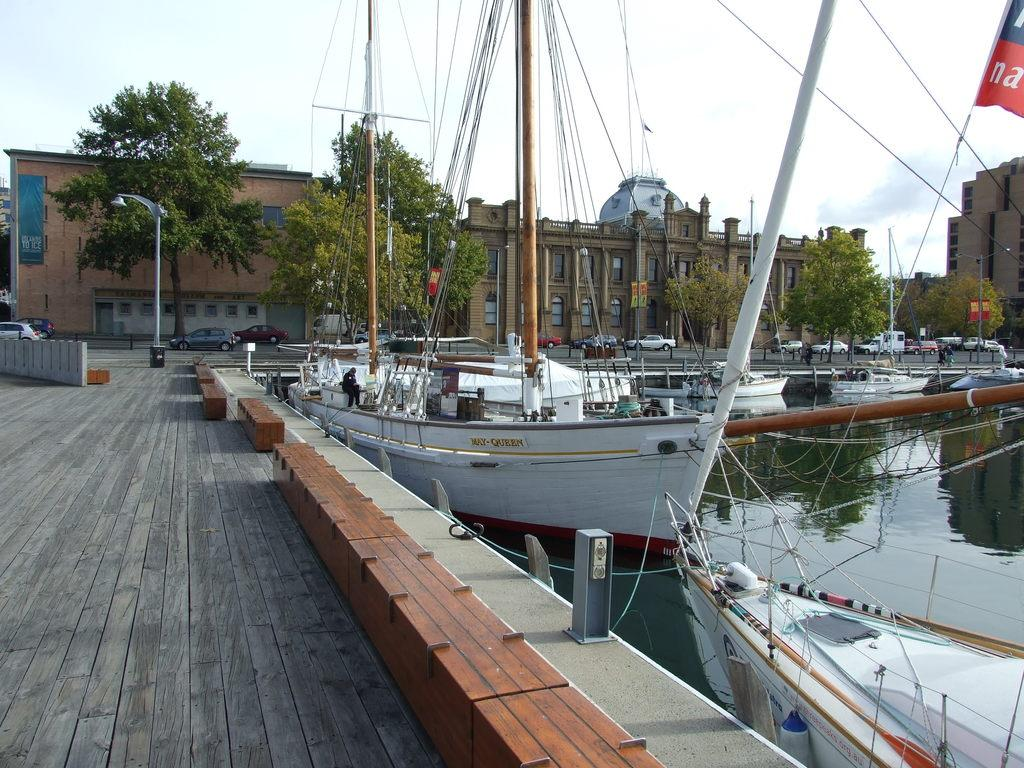What can be seen on the right side of the image? There are ships on the water on the right side of the image. What is visible in the background of the image? There are buildings, poles, trees, wires, and the sky visible in the background of the image. What type of vehicles are at the bottom of the image? There are cars at the bottom of the image. Where is the zipper located in the image? There is no zipper present in the image. What type of control is used to operate the ships in the image? The image does not show any controls for operating the ships; it only depicts the ships on the water. 